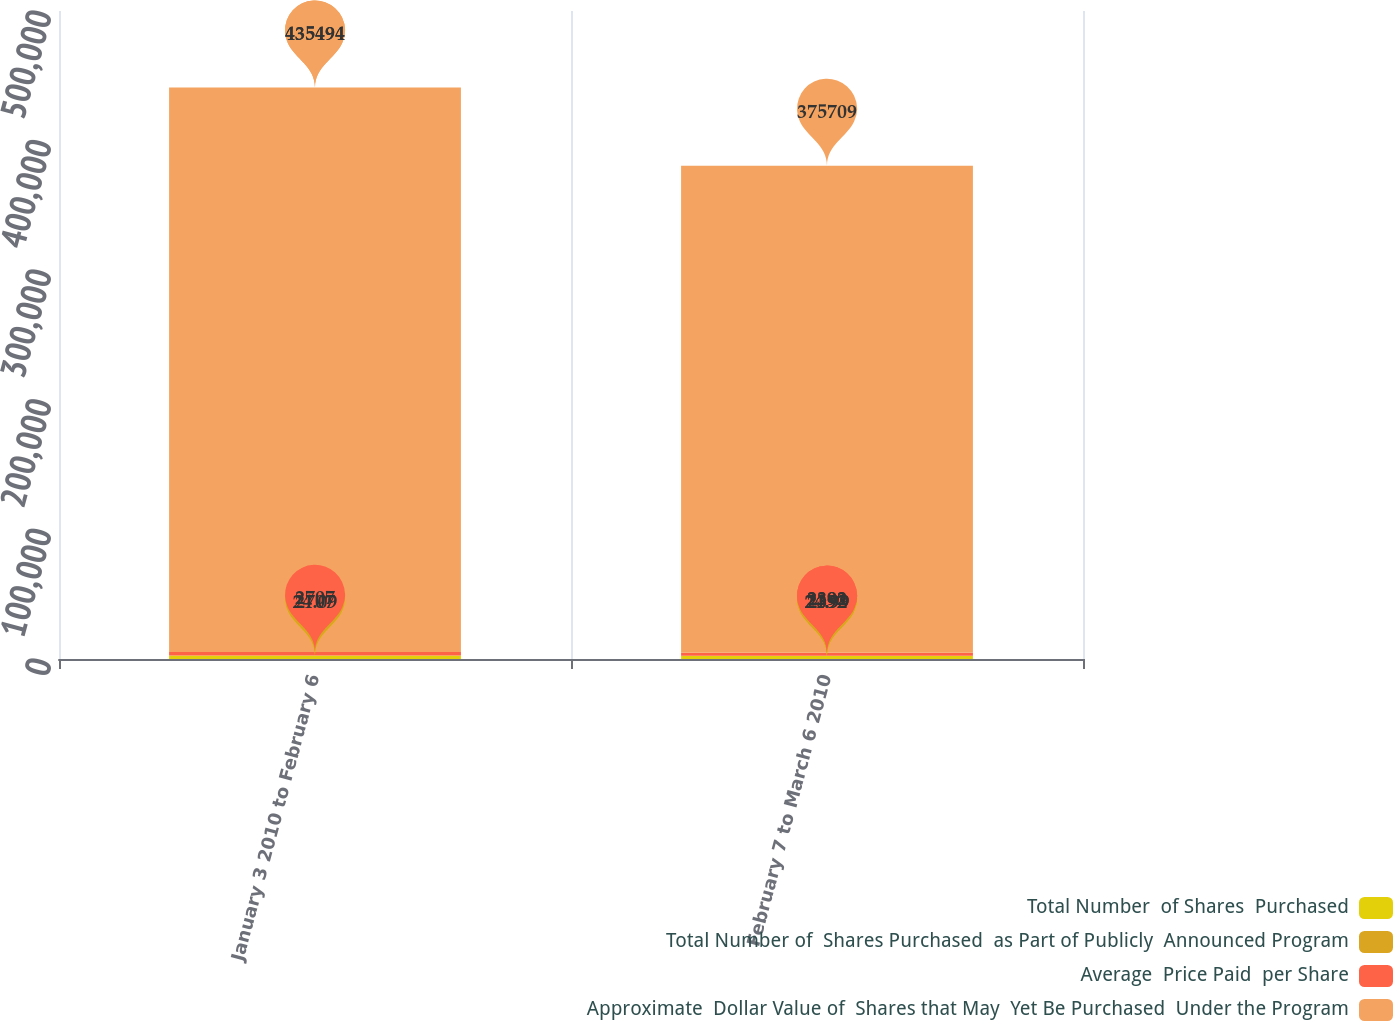<chart> <loc_0><loc_0><loc_500><loc_500><stacked_bar_chart><ecel><fcel>January 3 2010 to February 6<fcel>February 7 to March 6 2010<nl><fcel>Total Number  of Shares  Purchased<fcel>2707<fcel>2392<nl><fcel>Total Number of  Shares Purchased  as Part of Publicly  Announced Program<fcel>24.09<fcel>24.99<nl><fcel>Average  Price Paid  per Share<fcel>2707<fcel>2392<nl><fcel>Approximate  Dollar Value of  Shares that May  Yet Be Purchased  Under the Program<fcel>435494<fcel>375709<nl></chart> 